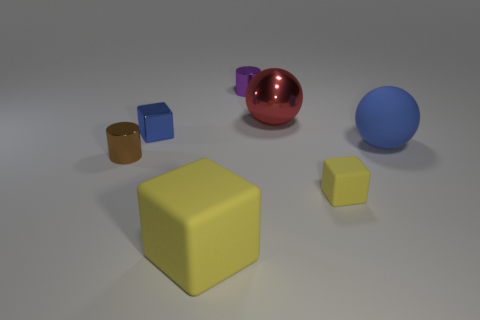What size is the shiny thing that is right of the brown cylinder and left of the big yellow object? The shiny object situated to the right of the brown cylinder and to the left of the big yellow cube appears to be small in size, roughly a quarter of the height of the yellow cube and smaller in diameter compared to the brown cylinder nearby. 